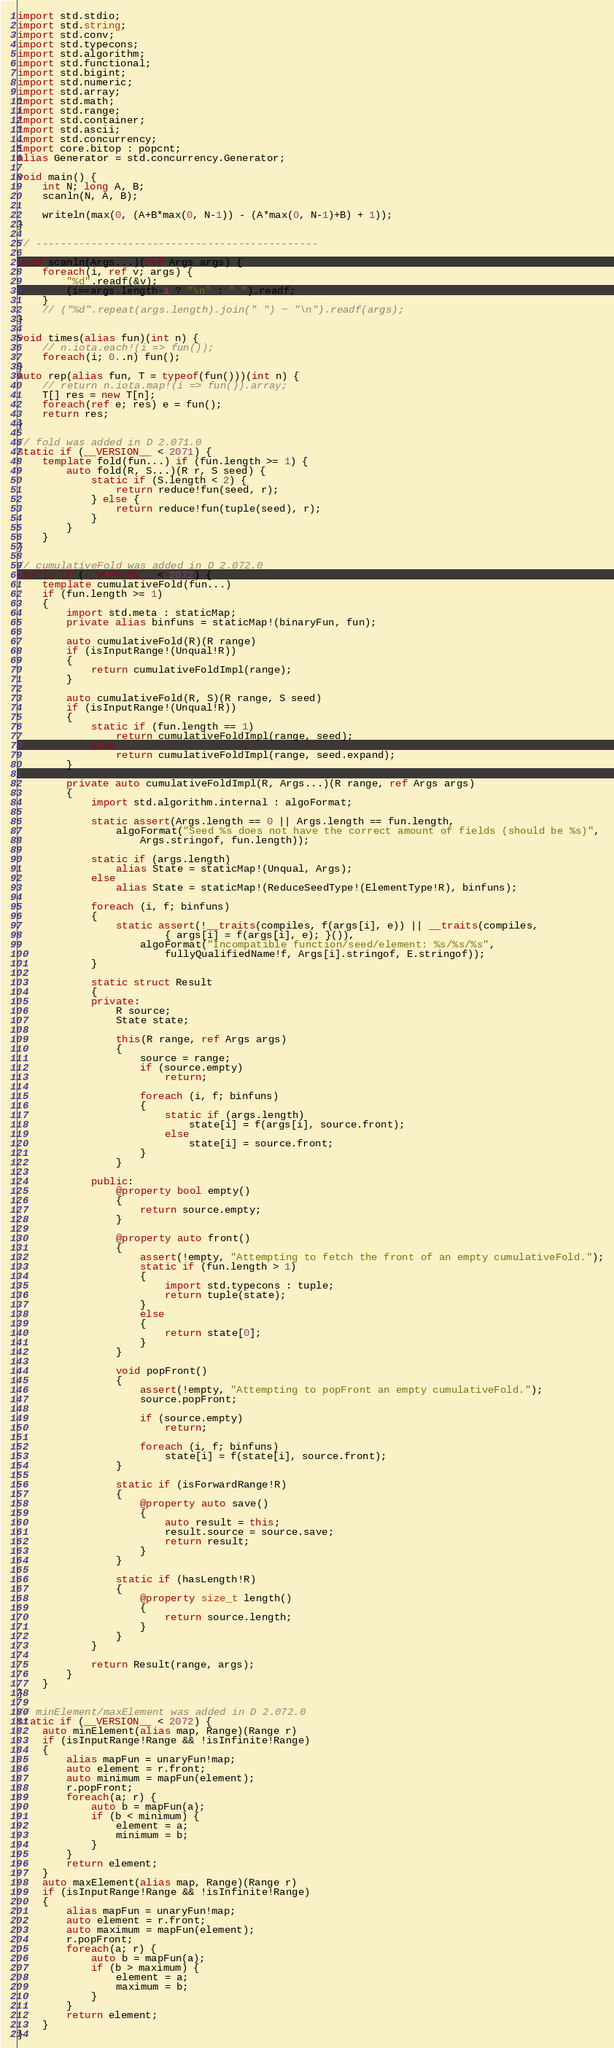Convert code to text. <code><loc_0><loc_0><loc_500><loc_500><_D_>import std.stdio;
import std.string;
import std.conv;
import std.typecons;
import std.algorithm;
import std.functional;
import std.bigint;
import std.numeric;
import std.array;
import std.math;
import std.range;
import std.container;
import std.ascii;
import std.concurrency;
import core.bitop : popcnt;
alias Generator = std.concurrency.Generator;

void main() {
    int N; long A, B;
    scanln(N, A, B);

    writeln(max(0, (A+B*max(0, N-1)) - (A*max(0, N-1)+B) + 1));
}

// ----------------------------------------------

void scanln(Args...)(ref Args args) {
    foreach(i, ref v; args) {
        "%d".readf(&v);
        (i==args.length-1 ? "\n" : " ").readf;
    }
    // ("%d".repeat(args.length).join(" ") ~ "\n").readf(args);
}

void times(alias fun)(int n) {
    // n.iota.each!(i => fun());
    foreach(i; 0..n) fun();
}
auto rep(alias fun, T = typeof(fun()))(int n) {
    // return n.iota.map!(i => fun()).array;
    T[] res = new T[n];
    foreach(ref e; res) e = fun();
    return res;
}

// fold was added in D 2.071.0
static if (__VERSION__ < 2071) {
    template fold(fun...) if (fun.length >= 1) {
        auto fold(R, S...)(R r, S seed) {
            static if (S.length < 2) {
                return reduce!fun(seed, r);
            } else {
                return reduce!fun(tuple(seed), r);
            }
        }
    }
}

// cumulativeFold was added in D 2.072.0
static if (__VERSION__ < 2072) {
    template cumulativeFold(fun...)
    if (fun.length >= 1)
    {
        import std.meta : staticMap;
        private alias binfuns = staticMap!(binaryFun, fun);

        auto cumulativeFold(R)(R range)
        if (isInputRange!(Unqual!R))
        {
            return cumulativeFoldImpl(range);
        }

        auto cumulativeFold(R, S)(R range, S seed)
        if (isInputRange!(Unqual!R))
        {
            static if (fun.length == 1)
                return cumulativeFoldImpl(range, seed);
            else
                return cumulativeFoldImpl(range, seed.expand);
        }

        private auto cumulativeFoldImpl(R, Args...)(R range, ref Args args)
        {
            import std.algorithm.internal : algoFormat;

            static assert(Args.length == 0 || Args.length == fun.length,
                algoFormat("Seed %s does not have the correct amount of fields (should be %s)",
                    Args.stringof, fun.length));

            static if (args.length)
                alias State = staticMap!(Unqual, Args);
            else
                alias State = staticMap!(ReduceSeedType!(ElementType!R), binfuns);

            foreach (i, f; binfuns)
            {
                static assert(!__traits(compiles, f(args[i], e)) || __traits(compiles,
                        { args[i] = f(args[i], e); }()),
                    algoFormat("Incompatible function/seed/element: %s/%s/%s",
                        fullyQualifiedName!f, Args[i].stringof, E.stringof));
            }

            static struct Result
            {
            private:
                R source;
                State state;

                this(R range, ref Args args)
                {
                    source = range;
                    if (source.empty)
                        return;

                    foreach (i, f; binfuns)
                    {
                        static if (args.length)
                            state[i] = f(args[i], source.front);
                        else
                            state[i] = source.front;
                    }
                }

            public:
                @property bool empty()
                {
                    return source.empty;
                }

                @property auto front()
                {
                    assert(!empty, "Attempting to fetch the front of an empty cumulativeFold.");
                    static if (fun.length > 1)
                    {
                        import std.typecons : tuple;
                        return tuple(state);
                    }
                    else
                    {
                        return state[0];
                    }
                }

                void popFront()
                {
                    assert(!empty, "Attempting to popFront an empty cumulativeFold.");
                    source.popFront;

                    if (source.empty)
                        return;

                    foreach (i, f; binfuns)
                        state[i] = f(state[i], source.front);
                }

                static if (isForwardRange!R)
                {
                    @property auto save()
                    {
                        auto result = this;
                        result.source = source.save;
                        return result;
                    }
                }

                static if (hasLength!R)
                {
                    @property size_t length()
                    {
                        return source.length;
                    }
                }
            }

            return Result(range, args);
        }
    }
}

// minElement/maxElement was added in D 2.072.0
static if (__VERSION__ < 2072) {
    auto minElement(alias map, Range)(Range r)
    if (isInputRange!Range && !isInfinite!Range)
    {
        alias mapFun = unaryFun!map;
        auto element = r.front;
        auto minimum = mapFun(element);
        r.popFront;
        foreach(a; r) {
            auto b = mapFun(a);
            if (b < minimum) {
                element = a;
                minimum = b;
            }
        }
        return element;
    }
    auto maxElement(alias map, Range)(Range r)
    if (isInputRange!Range && !isInfinite!Range)
    {
        alias mapFun = unaryFun!map;
        auto element = r.front;
        auto maximum = mapFun(element);
        r.popFront;
        foreach(a; r) {
            auto b = mapFun(a);
            if (b > maximum) {
                element = a;
                maximum = b;
            }
        }
        return element;
    }
}
</code> 